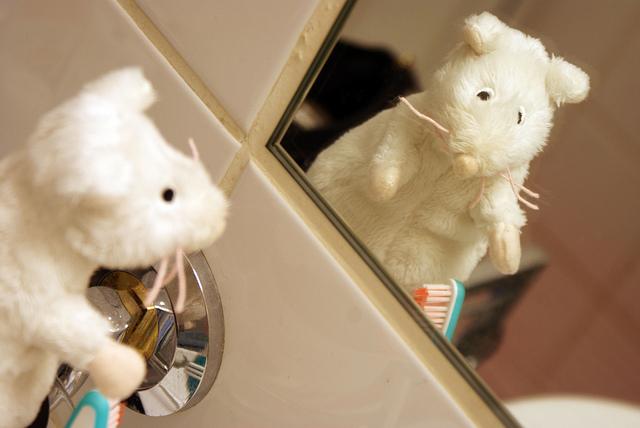Why can we see two mice in this photo?
Quick response, please. Mirror. How many stuffed animals?
Short answer required. 1. Is this a bathroom?
Be succinct. Yes. 